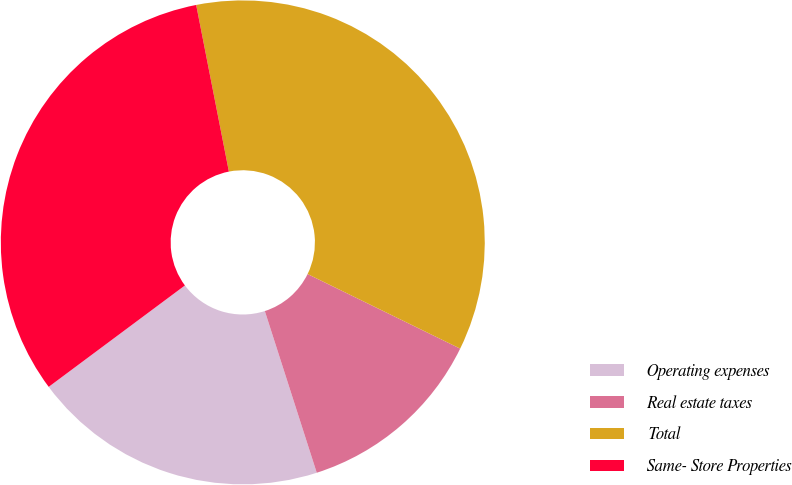Convert chart to OTSL. <chart><loc_0><loc_0><loc_500><loc_500><pie_chart><fcel>Operating expenses<fcel>Real estate taxes<fcel>Total<fcel>Same- Store Properties<nl><fcel>19.76%<fcel>12.82%<fcel>35.32%<fcel>32.1%<nl></chart> 